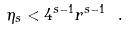<formula> <loc_0><loc_0><loc_500><loc_500>\eta _ { s } < 4 ^ { s - 1 } r ^ { s - 1 } \ .</formula> 